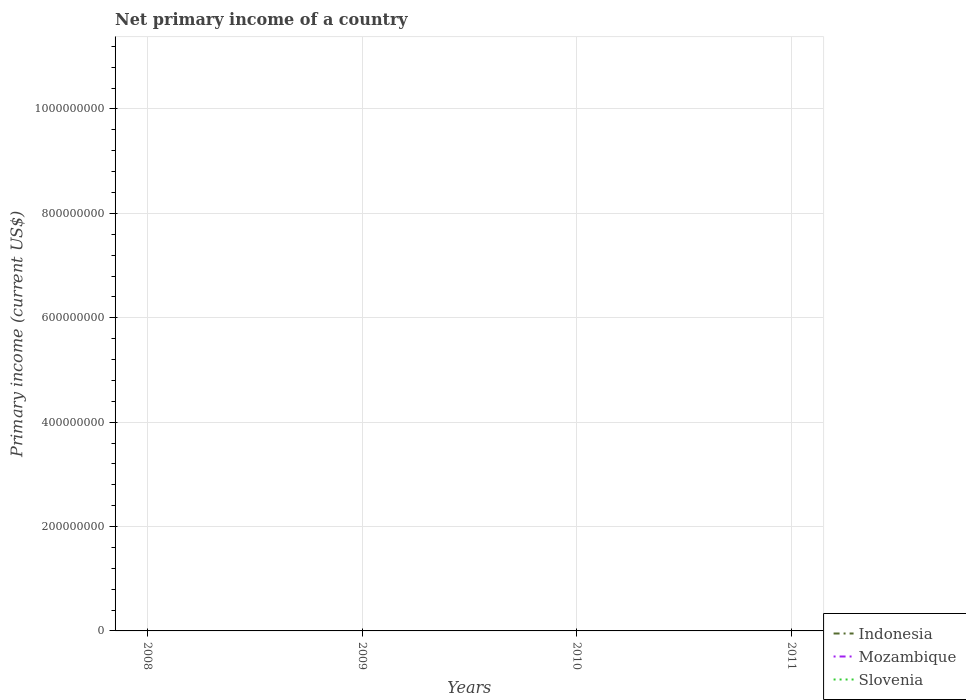Does the line corresponding to Slovenia intersect with the line corresponding to Indonesia?
Your answer should be very brief. No. How many lines are there?
Provide a succinct answer. 0. Where does the legend appear in the graph?
Give a very brief answer. Bottom right. How many legend labels are there?
Make the answer very short. 3. How are the legend labels stacked?
Provide a succinct answer. Vertical. What is the title of the graph?
Keep it short and to the point. Net primary income of a country. What is the label or title of the X-axis?
Offer a terse response. Years. What is the label or title of the Y-axis?
Ensure brevity in your answer.  Primary income (current US$). What is the Primary income (current US$) in Indonesia in 2008?
Offer a very short reply. 0. What is the Primary income (current US$) of Mozambique in 2008?
Give a very brief answer. 0. What is the Primary income (current US$) of Slovenia in 2008?
Make the answer very short. 0. What is the Primary income (current US$) of Indonesia in 2009?
Offer a terse response. 0. What is the Primary income (current US$) of Mozambique in 2009?
Offer a terse response. 0. What is the Primary income (current US$) of Indonesia in 2010?
Make the answer very short. 0. What is the Primary income (current US$) in Mozambique in 2010?
Ensure brevity in your answer.  0. What is the Primary income (current US$) in Mozambique in 2011?
Offer a terse response. 0. What is the Primary income (current US$) in Slovenia in 2011?
Your response must be concise. 0. What is the total Primary income (current US$) of Mozambique in the graph?
Your answer should be compact. 0. 